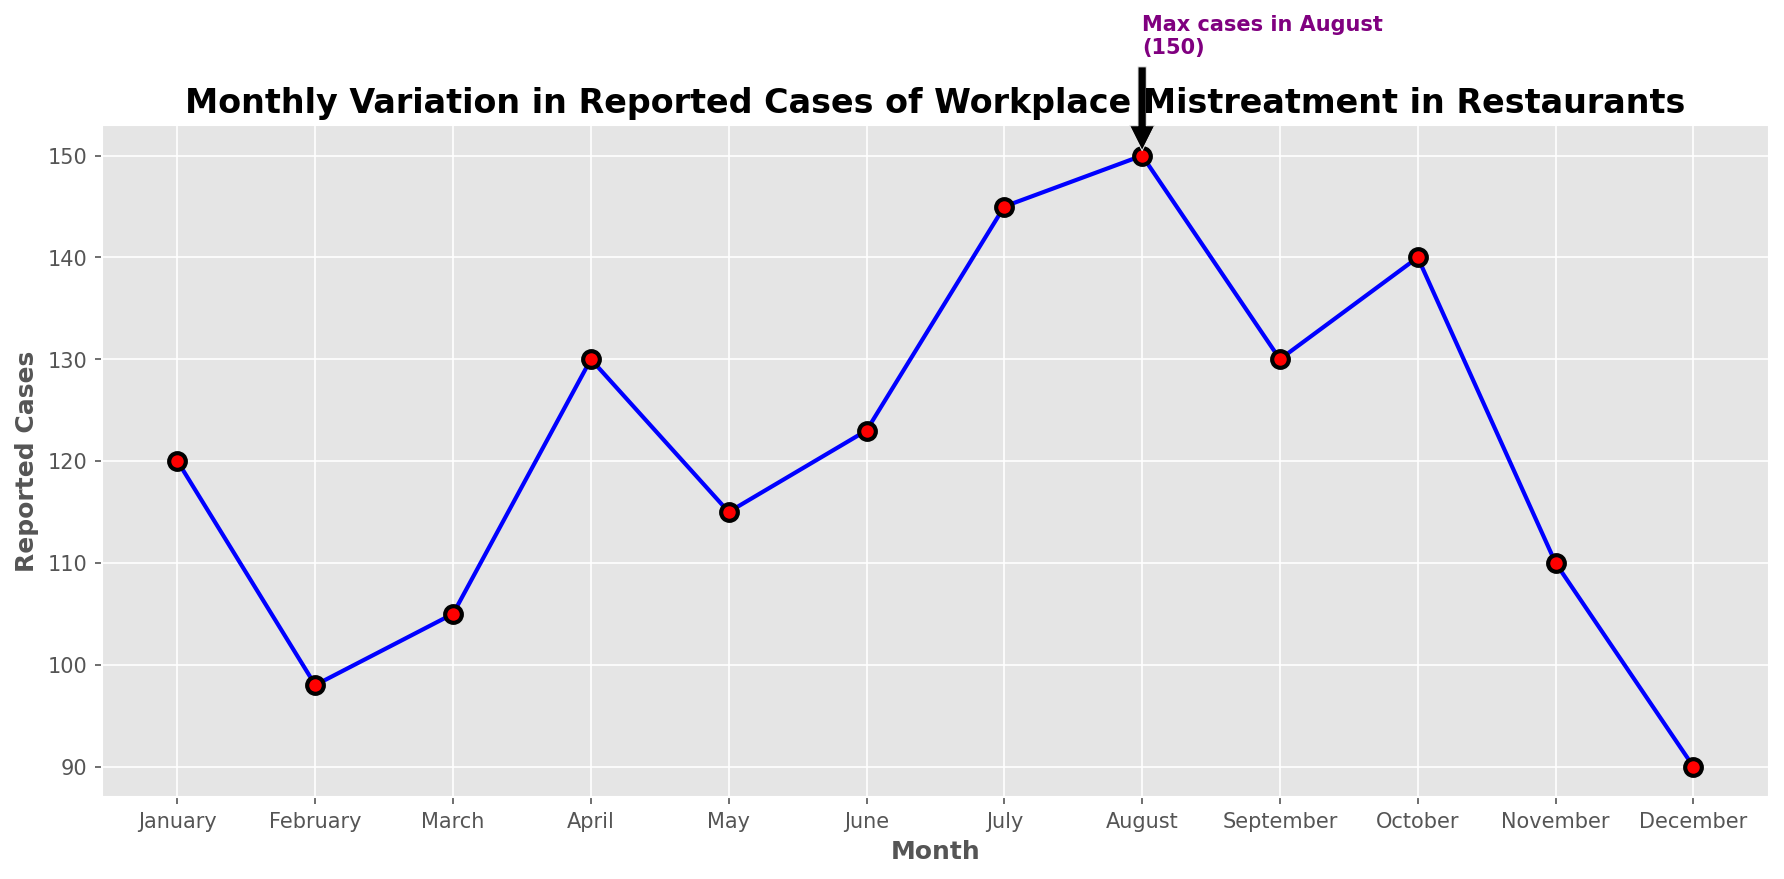What's the trend in reported cases of workplace mistreatment from January to December? The trend can be observed by looking at the line plot and noting the changes in reported cases as you move from January to December. The cases initially decrease from January to February, slightly increase in March, then rise to a peak in August followed by a decline towards December.
Answer: Increasing then decreasing Which month has the highest reported cases of workplace mistreatment? The highest point on the plot represents the month with the most reported cases. There is also a label indicating "Max cases in August (150)", identifying August as the month with the highest reported cases.
Answer: August How do the reported cases in April compare to those in May? By looking at the plot, we can compare the height of the points for April and May. April has 130 reported cases, while May has 115. Therefore, cases in April are higher than in May.
Answer: April is higher What is the difference in reported cases between July and December? Observe the heights of the points for July and December on the plot. July has 145 reported cases and December has 90. Subtracting these values gives a difference of 55.
Answer: 55 What is the average number of reported cases over the year? Sum all the reported cases across the months (120 + 98 + 105 + 130 + 115 + 123 + 145 + 150 + 130 + 140 + 110 + 90) and then divide by 12 to get the average: (1456 / 12) = 121.33.
Answer: 121.33 Which months have reported cases more than 130? Look at the plot and identify the months where the points are above 130. The months that fit this criterion are July, August, and October.
Answer: July, August, October How much do the reported cases increase from February to March? By examining the height of the points for February and March, February has 98 reported cases and March has 105. The increase is found by subtracting February's cases from March's cases: (105 - 98) = 7.
Answer: 7 What color are the markers on the plot? Observing the visual attributes of the line plot, the markers are red with black edges.
Answer: Red with black edges Why is there a text annotation on the plot? The annotation indicates the month with the highest reported cases of workplace mistreatment, aiding in quickly identifying the peak of the plot. It highlights "Max cases in August (150)" showing that August had the highest reported cases.
Answer: To indicate the peak Which two consecutive months show the largest increase in reported cases? Compare the differences in reported cases between consecutive months by looking at the height differences between them. The largest increase is between June (123) and July (145), showing an increase of (145 - 123) = 22 cases.
Answer: June to July 